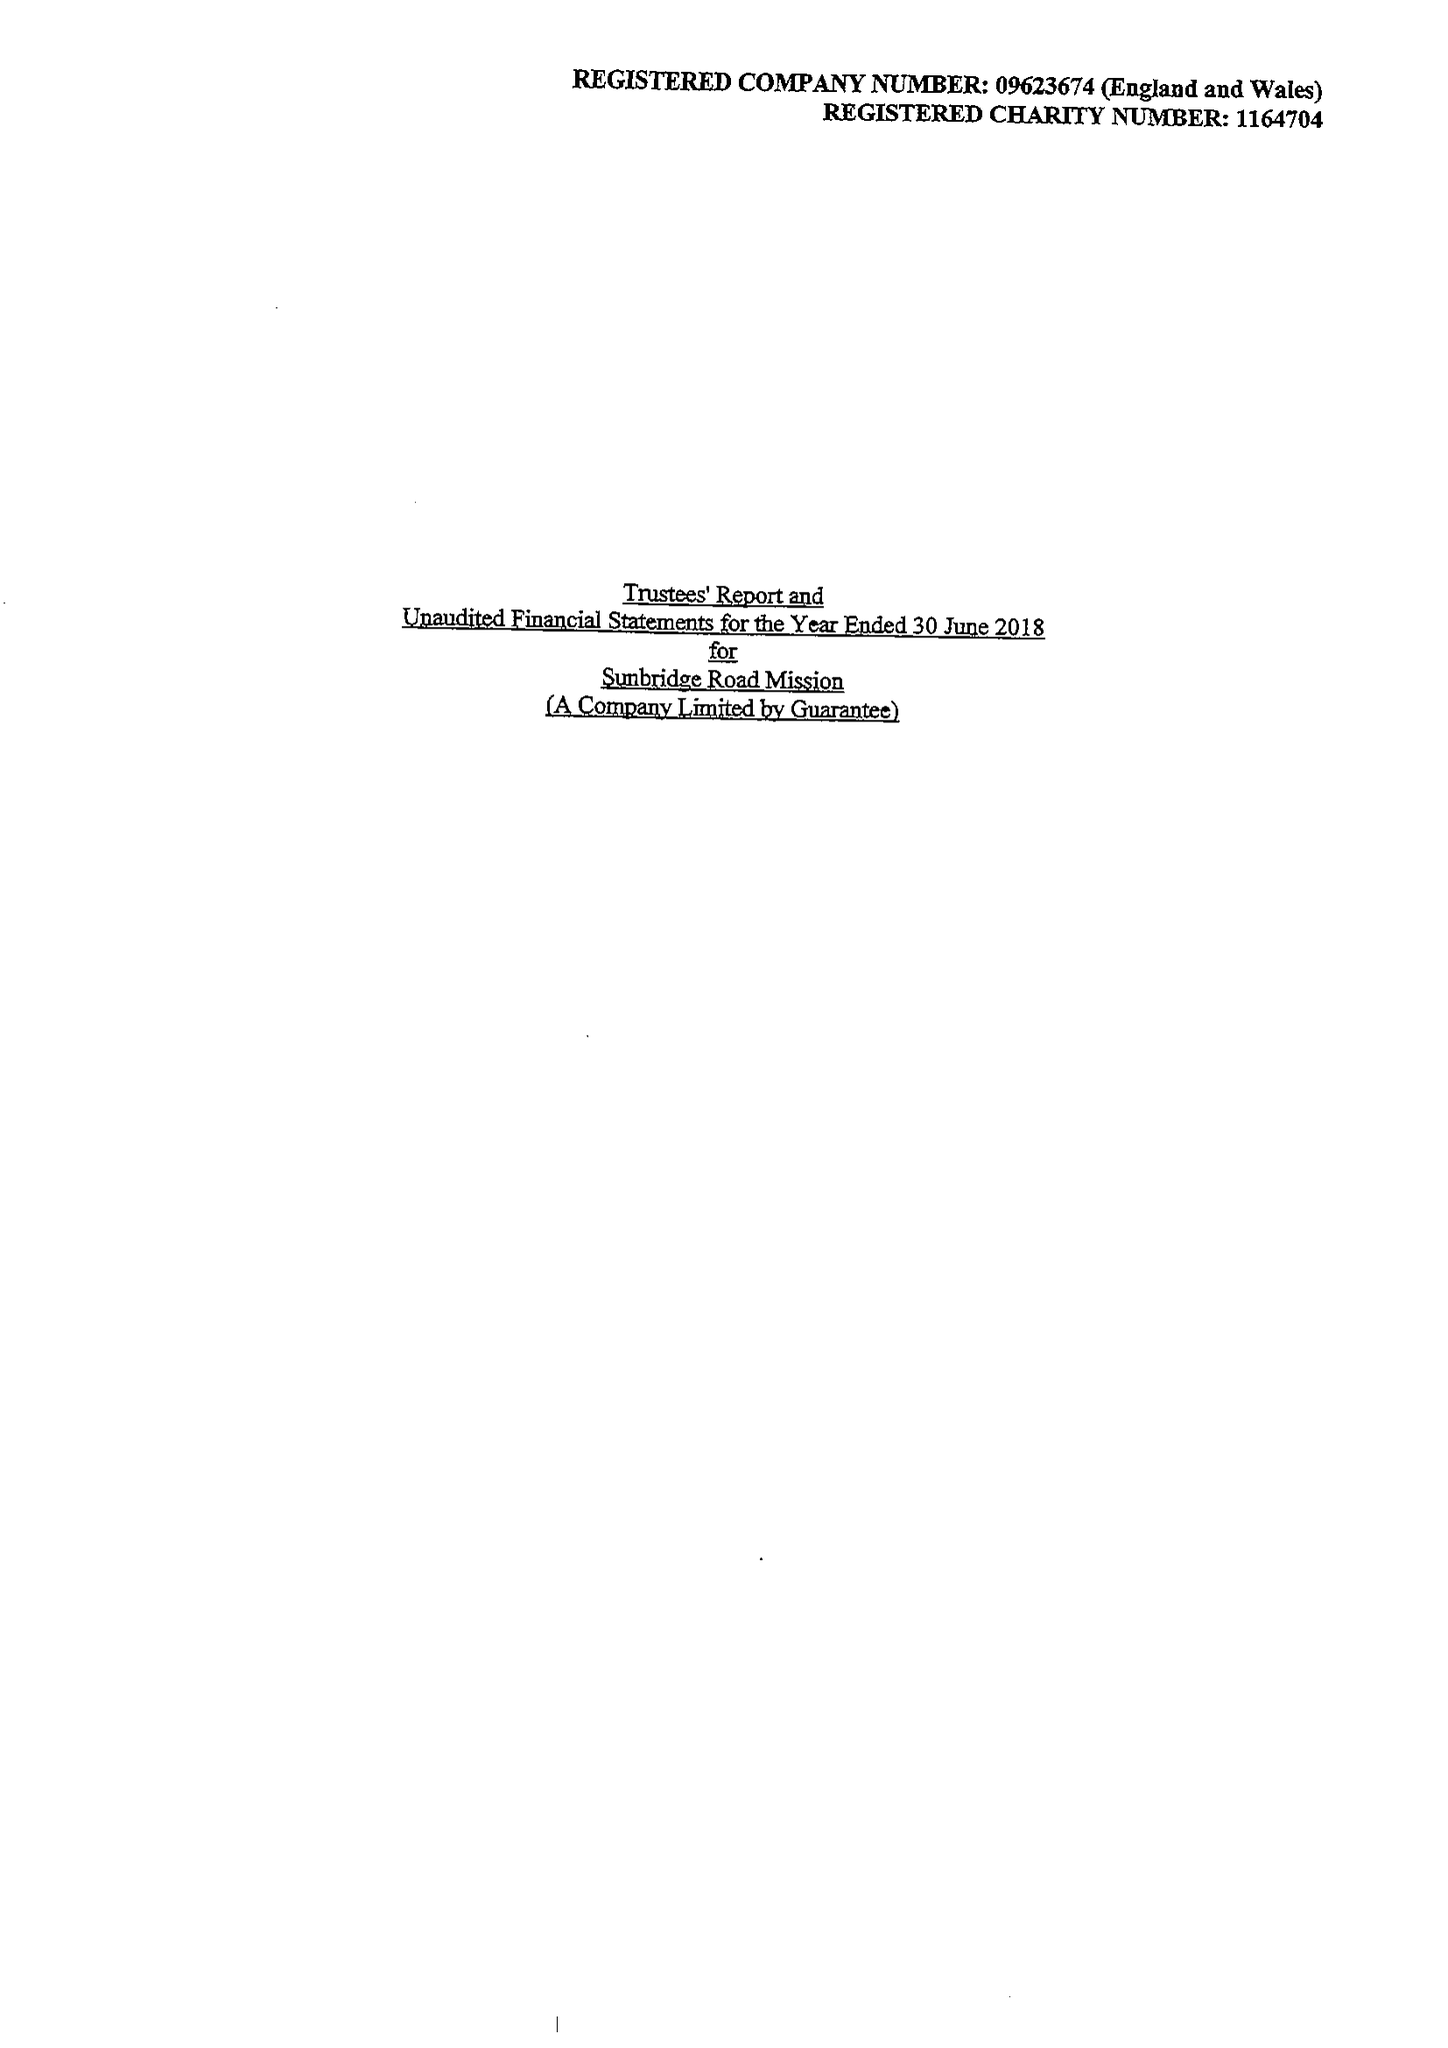What is the value for the income_annually_in_british_pounds?
Answer the question using a single word or phrase. 278550.00 